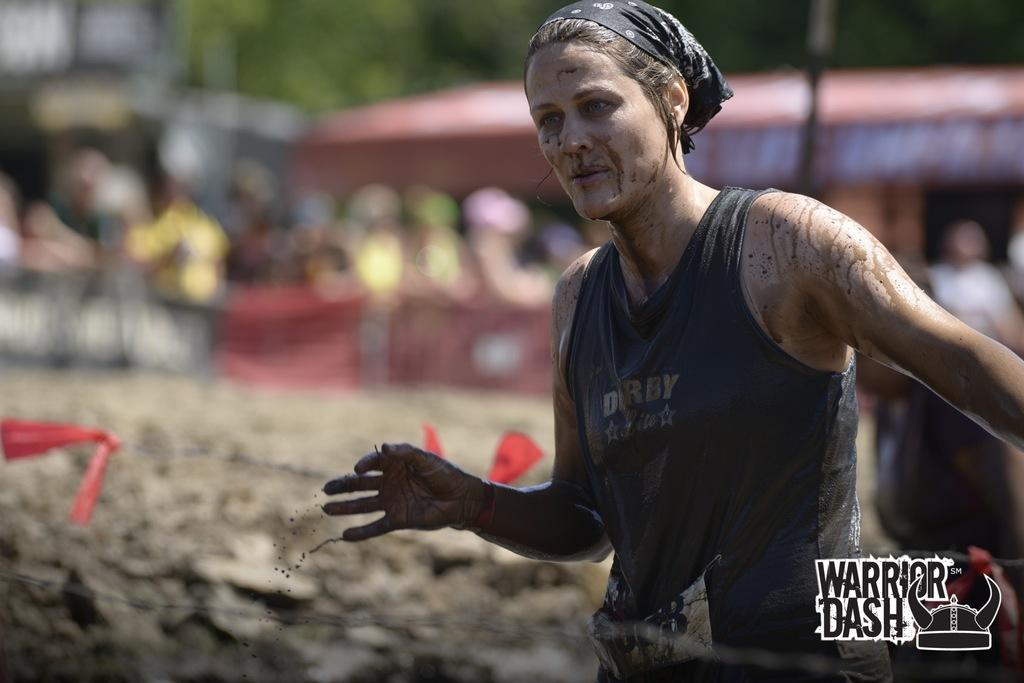Who is the main subject in the image? There is a woman in the image. Where is the woman located in the image? The woman is on the right side of the image. What is the woman wearing in the image? The woman is wearing a black color top and has a scarf on her head. What can be seen at the bottom of the image? There is a metal wire at the bottom of the image. What type of faucet can be seen in the image? There is no faucet present in the image. Is the woman in jail in the image? There is no indication in the image that the woman is in jail. 